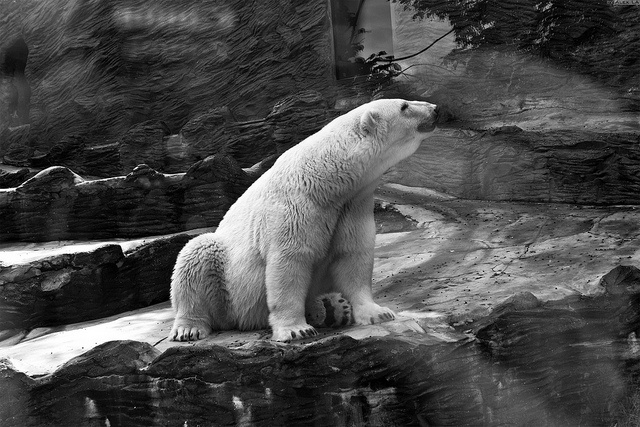Describe the objects in this image and their specific colors. I can see a bear in gray, darkgray, lightgray, and black tones in this image. 